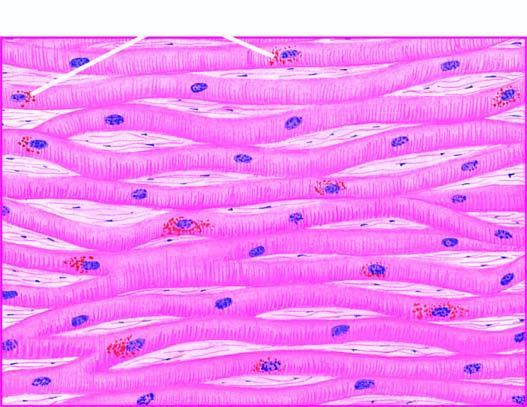what are seen in the cytoplasm of the myocardial fibres, especially around the nuclei?
Answer the question using a single word or phrase. Lipofuscin pigment granules nuclei 